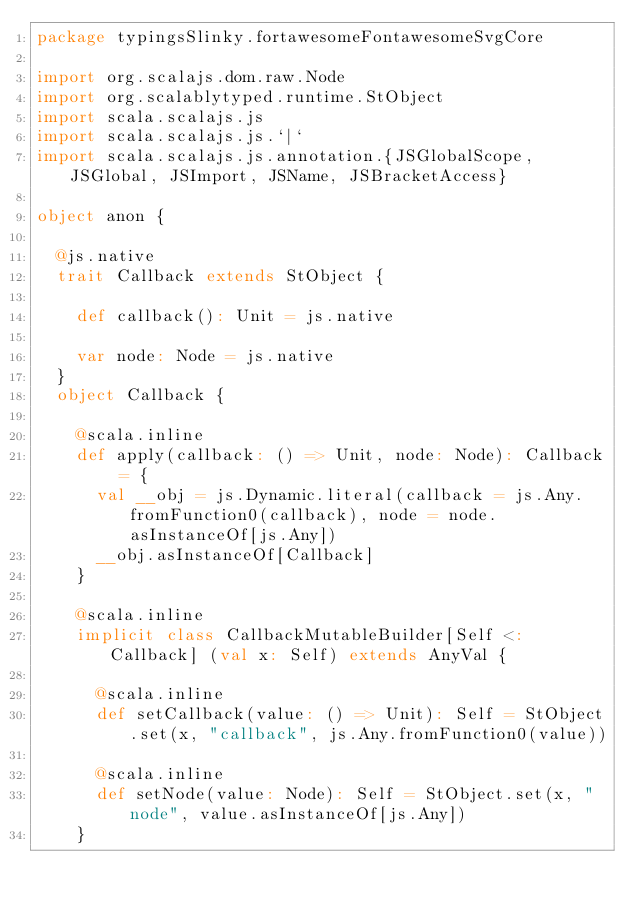Convert code to text. <code><loc_0><loc_0><loc_500><loc_500><_Scala_>package typingsSlinky.fortawesomeFontawesomeSvgCore

import org.scalajs.dom.raw.Node
import org.scalablytyped.runtime.StObject
import scala.scalajs.js
import scala.scalajs.js.`|`
import scala.scalajs.js.annotation.{JSGlobalScope, JSGlobal, JSImport, JSName, JSBracketAccess}

object anon {
  
  @js.native
  trait Callback extends StObject {
    
    def callback(): Unit = js.native
    
    var node: Node = js.native
  }
  object Callback {
    
    @scala.inline
    def apply(callback: () => Unit, node: Node): Callback = {
      val __obj = js.Dynamic.literal(callback = js.Any.fromFunction0(callback), node = node.asInstanceOf[js.Any])
      __obj.asInstanceOf[Callback]
    }
    
    @scala.inline
    implicit class CallbackMutableBuilder[Self <: Callback] (val x: Self) extends AnyVal {
      
      @scala.inline
      def setCallback(value: () => Unit): Self = StObject.set(x, "callback", js.Any.fromFunction0(value))
      
      @scala.inline
      def setNode(value: Node): Self = StObject.set(x, "node", value.asInstanceOf[js.Any])
    }</code> 